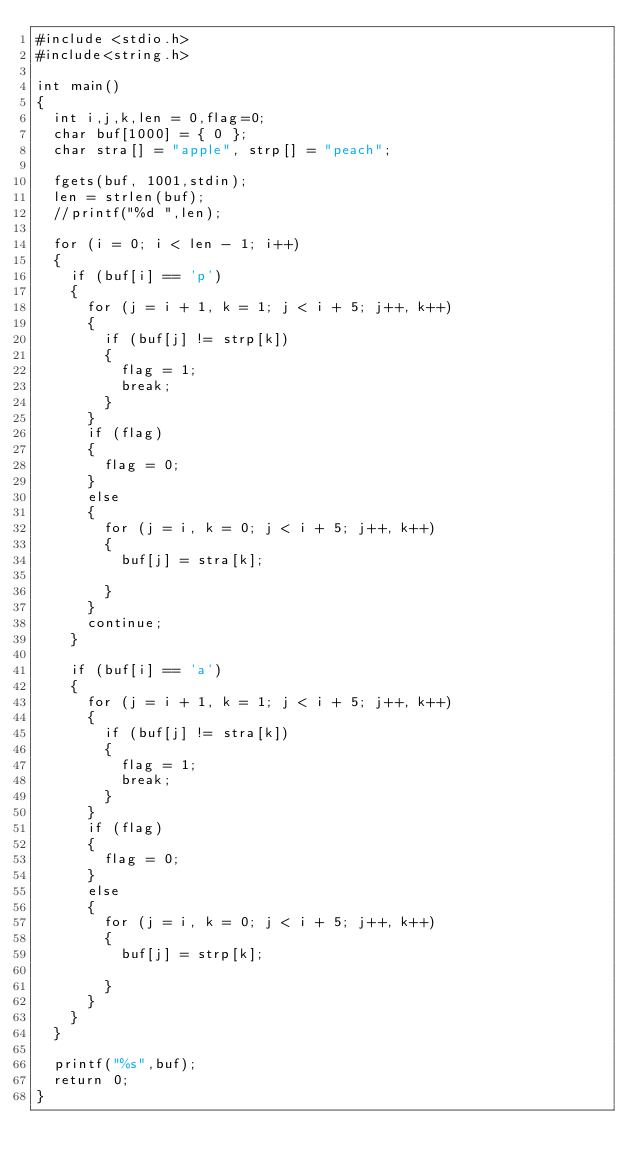Convert code to text. <code><loc_0><loc_0><loc_500><loc_500><_C_>#include <stdio.h>
#include<string.h>

int main()
{
	int i,j,k,len = 0,flag=0;
	char buf[1000] = { 0 };
	char stra[] = "apple", strp[] = "peach";
	
	fgets(buf, 1001,stdin);
	len = strlen(buf);
	//printf("%d ",len);

	for (i = 0; i < len - 1; i++)
	{
		if (buf[i] == 'p')
		{
			for (j = i + 1, k = 1; j < i + 5; j++, k++)
			{
				if (buf[j] != strp[k])
				{
					flag = 1;
					break;
				}
			}
			if (flag)
			{
				flag = 0;
			}
			else
			{
				for (j = i, k = 0; j < i + 5; j++, k++)
				{
					buf[j] = stra[k];

				}
			}
			continue;
		}

		if (buf[i] == 'a')
		{
			for (j = i + 1, k = 1; j < i + 5; j++, k++)
			{
				if (buf[j] != stra[k])
				{
					flag = 1;
					break;
				}
			}
			if (flag)
			{
				flag = 0;
			}
			else
			{
				for (j = i, k = 0; j < i + 5; j++, k++)
				{
					buf[j] = strp[k];

				}
			}
		}
	}

	printf("%s",buf);
	return 0;
}
</code> 